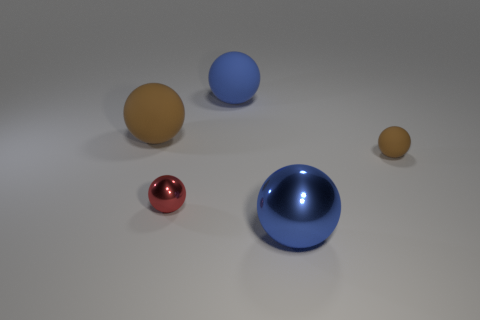Subtract 3 spheres. How many spheres are left? 2 Subtract all tiny brown balls. How many balls are left? 4 Subtract all red spheres. How many spheres are left? 4 Add 1 red metallic balls. How many objects exist? 6 Subtract all purple spheres. Subtract all purple cylinders. How many spheres are left? 5 Add 5 big brown spheres. How many big brown spheres exist? 6 Subtract 0 blue cylinders. How many objects are left? 5 Subtract all tiny purple shiny spheres. Subtract all blue shiny objects. How many objects are left? 4 Add 1 red metallic things. How many red metallic things are left? 2 